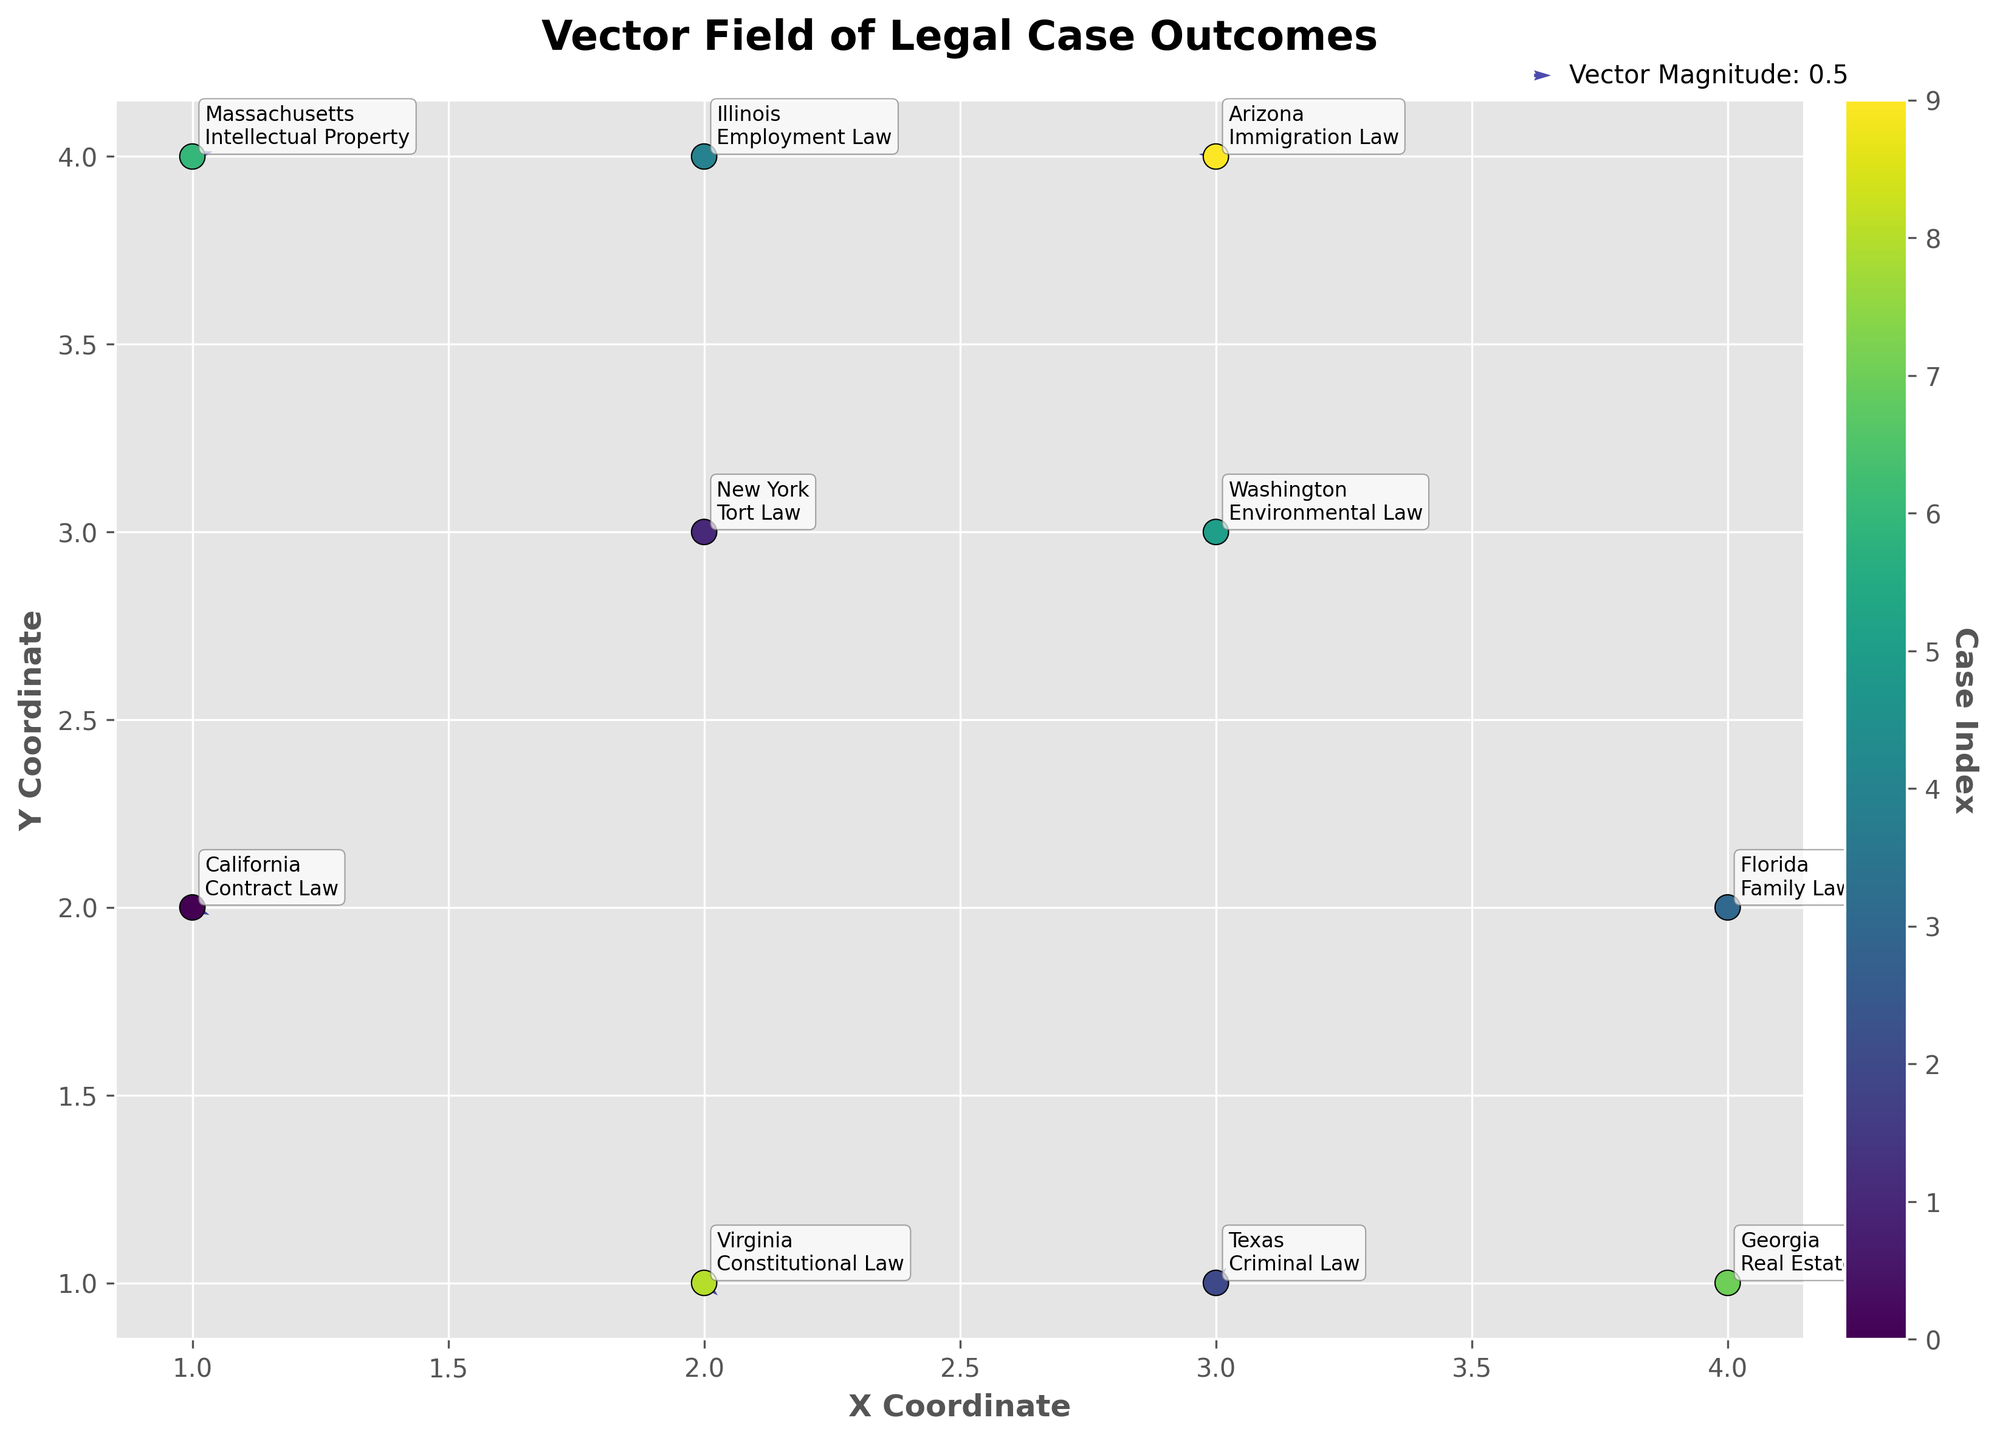What is the title of the plot? The title is displayed at the top of the figure in a bold and larger font compared to other texts on the plot.
Answer: Vector Field of Legal Case Outcomes How many data points are plotted? Each point represents a unique combination of X and Y coordinates. By counting these unique points, we can see there are 10 data points.
Answer: 10 Which jurisdiction and law type can be found at coordinates (1, 4)? Locate the point at (1, 4) and read the annotation near it. The annotation shows both the jurisdiction and law type for that point.
Answer: Massachusetts, Intellectual Property Which vector has the highest positive X component? Look at the vectors' U components to find the largest positive value. The vector at (1, 4) has a U component of 0.6, which is the highest.
Answer: The vector at (1, 4) with Massachusetts, Intellectual Property What is the direction of the vector at coordinates (3, 4)? Find the vector at (3, 4) and observe its direction based on its U and V components. The vector's U component is -0.5, making it point left, and V component is 0.1, slightly upward.
Answer: Left and slightly upward Which jurisdiction has a decreasing trend in the Y direction with an increasing trend in the X direction? Find the vectors where the V component is negative and the U component is positive. The vector at (2, 1) has U=0.4 and V=-0.5.
Answer: Virginia Which data point has the largest vector magnitude (use sqrt(U^2 + V^2))? Calculate the magnitude for each vector. The vector for California at (1, 2) has U=0.5 and V=-0.3; magnitude is sqrt(0.5^2 + (-0.3)^2) = sqrt(0.34) ≈ 0.583. Compare this with other vectors. The vector at (3, 1) for Texas has U=0.3 and V=0.6; magnitude is sqrt(0.3^2 + 0.6^2) = sqrt(0.45) ≈ 0.671, which is the largest.
Answer: The vector at (3, 1) with Texas, Criminal Law Which jurisdiction's vector points the most downward? Look for the vector with the most negative V component among all jurisdictions. The vector at (2, 1) for Virginia has V=-0.5, which is the most downward.
Answer: Virginia What is the average U component of the vectors? Sum the U components (0.5 + (-0.2) + 0.3 + (-0.4) + 0.1 + (-0.3) + 0.6 + (-0.1) + 0.4 + (-0.5)), and divide by the number of points (10). The sum is 0.4, so the average is 0.4/10 = 0.04.
Answer: 0.04 What is the X-axis label? The label is positioned along the X-axis of the plot and is typically in bold.
Answer: X Coordinate 